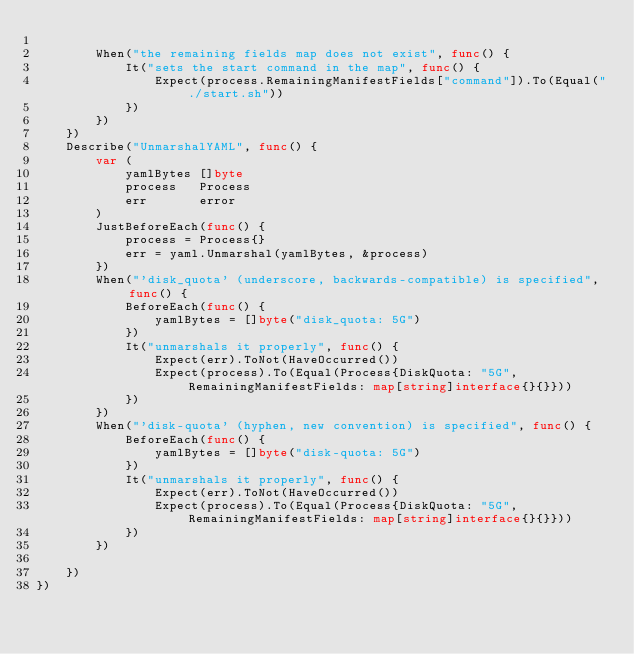Convert code to text. <code><loc_0><loc_0><loc_500><loc_500><_Go_>
		When("the remaining fields map does not exist", func() {
			It("sets the start command in the map", func() {
				Expect(process.RemainingManifestFields["command"]).To(Equal("./start.sh"))
			})
		})
	})
	Describe("UnmarshalYAML", func() {
		var (
			yamlBytes []byte
			process   Process
			err       error
		)
		JustBeforeEach(func() {
			process = Process{}
			err = yaml.Unmarshal(yamlBytes, &process)
		})
		When("'disk_quota' (underscore, backwards-compatible) is specified", func() {
			BeforeEach(func() {
				yamlBytes = []byte("disk_quota: 5G")
			})
			It("unmarshals it properly", func() {
				Expect(err).ToNot(HaveOccurred())
				Expect(process).To(Equal(Process{DiskQuota: "5G", RemainingManifestFields: map[string]interface{}{}}))
			})
		})
		When("'disk-quota' (hyphen, new convention) is specified", func() {
			BeforeEach(func() {
				yamlBytes = []byte("disk-quota: 5G")
			})
			It("unmarshals it properly", func() {
				Expect(err).ToNot(HaveOccurred())
				Expect(process).To(Equal(Process{DiskQuota: "5G", RemainingManifestFields: map[string]interface{}{}}))
			})
		})

	})
})
</code> 